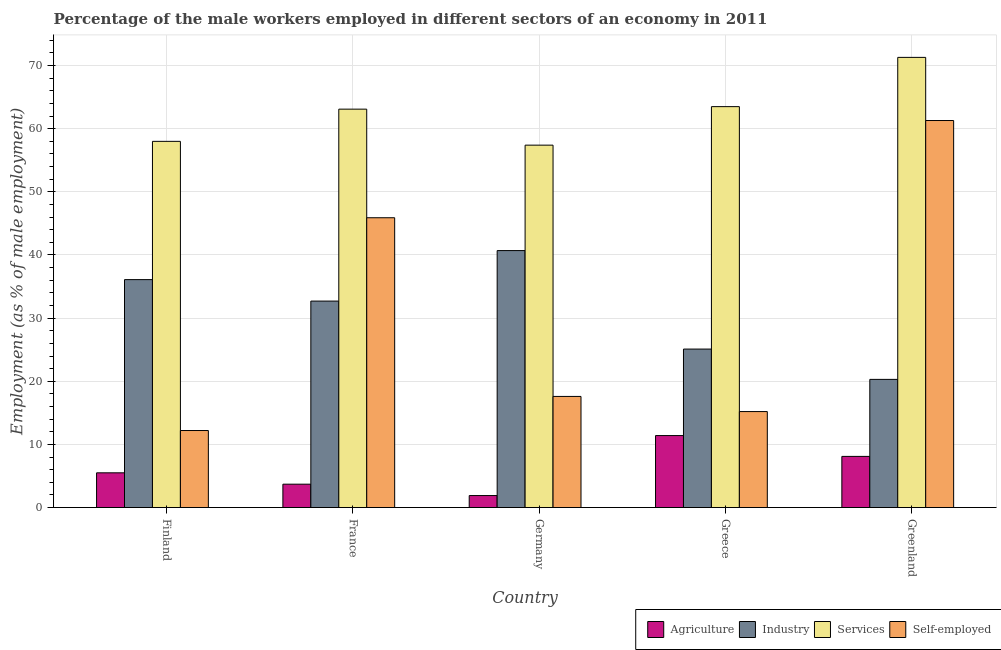How many different coloured bars are there?
Keep it short and to the point. 4. How many groups of bars are there?
Your response must be concise. 5. Are the number of bars on each tick of the X-axis equal?
Provide a succinct answer. Yes. What is the label of the 5th group of bars from the left?
Keep it short and to the point. Greenland. What is the percentage of male workers in industry in France?
Your answer should be very brief. 32.7. Across all countries, what is the maximum percentage of self employed male workers?
Give a very brief answer. 61.3. Across all countries, what is the minimum percentage of male workers in services?
Offer a very short reply. 57.4. In which country was the percentage of male workers in services minimum?
Make the answer very short. Germany. What is the total percentage of self employed male workers in the graph?
Offer a terse response. 152.2. What is the difference between the percentage of self employed male workers in Finland and that in Germany?
Offer a very short reply. -5.4. What is the difference between the percentage of self employed male workers in Greece and the percentage of male workers in industry in Finland?
Provide a short and direct response. -20.9. What is the average percentage of male workers in services per country?
Provide a short and direct response. 62.66. What is the difference between the percentage of male workers in industry and percentage of male workers in services in Germany?
Offer a terse response. -16.7. What is the ratio of the percentage of self employed male workers in Finland to that in Greenland?
Keep it short and to the point. 0.2. What is the difference between the highest and the second highest percentage of male workers in agriculture?
Make the answer very short. 3.3. What is the difference between the highest and the lowest percentage of male workers in industry?
Offer a very short reply. 20.4. Is the sum of the percentage of male workers in industry in France and Germany greater than the maximum percentage of male workers in services across all countries?
Your answer should be compact. Yes. Is it the case that in every country, the sum of the percentage of male workers in services and percentage of self employed male workers is greater than the sum of percentage of male workers in agriculture and percentage of male workers in industry?
Give a very brief answer. Yes. What does the 3rd bar from the left in Germany represents?
Make the answer very short. Services. What does the 3rd bar from the right in Greece represents?
Make the answer very short. Industry. Is it the case that in every country, the sum of the percentage of male workers in agriculture and percentage of male workers in industry is greater than the percentage of male workers in services?
Your response must be concise. No. Are all the bars in the graph horizontal?
Your answer should be very brief. No. What is the difference between two consecutive major ticks on the Y-axis?
Your answer should be compact. 10. Does the graph contain any zero values?
Make the answer very short. No. Where does the legend appear in the graph?
Ensure brevity in your answer.  Bottom right. How many legend labels are there?
Keep it short and to the point. 4. How are the legend labels stacked?
Your answer should be very brief. Horizontal. What is the title of the graph?
Keep it short and to the point. Percentage of the male workers employed in different sectors of an economy in 2011. What is the label or title of the X-axis?
Make the answer very short. Country. What is the label or title of the Y-axis?
Make the answer very short. Employment (as % of male employment). What is the Employment (as % of male employment) in Industry in Finland?
Ensure brevity in your answer.  36.1. What is the Employment (as % of male employment) in Self-employed in Finland?
Your answer should be compact. 12.2. What is the Employment (as % of male employment) of Agriculture in France?
Offer a very short reply. 3.7. What is the Employment (as % of male employment) in Industry in France?
Offer a terse response. 32.7. What is the Employment (as % of male employment) in Services in France?
Offer a very short reply. 63.1. What is the Employment (as % of male employment) in Self-employed in France?
Make the answer very short. 45.9. What is the Employment (as % of male employment) of Agriculture in Germany?
Ensure brevity in your answer.  1.9. What is the Employment (as % of male employment) in Industry in Germany?
Your answer should be compact. 40.7. What is the Employment (as % of male employment) in Services in Germany?
Offer a terse response. 57.4. What is the Employment (as % of male employment) of Self-employed in Germany?
Make the answer very short. 17.6. What is the Employment (as % of male employment) in Agriculture in Greece?
Offer a terse response. 11.4. What is the Employment (as % of male employment) of Industry in Greece?
Your response must be concise. 25.1. What is the Employment (as % of male employment) of Services in Greece?
Offer a very short reply. 63.5. What is the Employment (as % of male employment) in Self-employed in Greece?
Your answer should be very brief. 15.2. What is the Employment (as % of male employment) of Agriculture in Greenland?
Make the answer very short. 8.1. What is the Employment (as % of male employment) in Industry in Greenland?
Give a very brief answer. 20.3. What is the Employment (as % of male employment) of Services in Greenland?
Offer a terse response. 71.3. What is the Employment (as % of male employment) of Self-employed in Greenland?
Give a very brief answer. 61.3. Across all countries, what is the maximum Employment (as % of male employment) of Agriculture?
Your answer should be very brief. 11.4. Across all countries, what is the maximum Employment (as % of male employment) of Industry?
Make the answer very short. 40.7. Across all countries, what is the maximum Employment (as % of male employment) of Services?
Provide a succinct answer. 71.3. Across all countries, what is the maximum Employment (as % of male employment) of Self-employed?
Your response must be concise. 61.3. Across all countries, what is the minimum Employment (as % of male employment) of Agriculture?
Provide a succinct answer. 1.9. Across all countries, what is the minimum Employment (as % of male employment) of Industry?
Ensure brevity in your answer.  20.3. Across all countries, what is the minimum Employment (as % of male employment) of Services?
Make the answer very short. 57.4. Across all countries, what is the minimum Employment (as % of male employment) in Self-employed?
Provide a succinct answer. 12.2. What is the total Employment (as % of male employment) of Agriculture in the graph?
Your answer should be very brief. 30.6. What is the total Employment (as % of male employment) in Industry in the graph?
Keep it short and to the point. 154.9. What is the total Employment (as % of male employment) of Services in the graph?
Give a very brief answer. 313.3. What is the total Employment (as % of male employment) of Self-employed in the graph?
Offer a very short reply. 152.2. What is the difference between the Employment (as % of male employment) of Self-employed in Finland and that in France?
Offer a terse response. -33.7. What is the difference between the Employment (as % of male employment) of Agriculture in Finland and that in Germany?
Offer a very short reply. 3.6. What is the difference between the Employment (as % of male employment) of Industry in Finland and that in Germany?
Your response must be concise. -4.6. What is the difference between the Employment (as % of male employment) in Services in Finland and that in Germany?
Provide a short and direct response. 0.6. What is the difference between the Employment (as % of male employment) in Agriculture in Finland and that in Greece?
Provide a short and direct response. -5.9. What is the difference between the Employment (as % of male employment) of Self-employed in Finland and that in Greece?
Your answer should be very brief. -3. What is the difference between the Employment (as % of male employment) of Agriculture in Finland and that in Greenland?
Ensure brevity in your answer.  -2.6. What is the difference between the Employment (as % of male employment) in Industry in Finland and that in Greenland?
Your answer should be very brief. 15.8. What is the difference between the Employment (as % of male employment) of Self-employed in Finland and that in Greenland?
Provide a short and direct response. -49.1. What is the difference between the Employment (as % of male employment) in Agriculture in France and that in Germany?
Offer a very short reply. 1.8. What is the difference between the Employment (as % of male employment) in Industry in France and that in Germany?
Provide a short and direct response. -8. What is the difference between the Employment (as % of male employment) of Services in France and that in Germany?
Offer a very short reply. 5.7. What is the difference between the Employment (as % of male employment) of Self-employed in France and that in Germany?
Your answer should be very brief. 28.3. What is the difference between the Employment (as % of male employment) of Agriculture in France and that in Greece?
Ensure brevity in your answer.  -7.7. What is the difference between the Employment (as % of male employment) of Industry in France and that in Greece?
Keep it short and to the point. 7.6. What is the difference between the Employment (as % of male employment) in Services in France and that in Greece?
Your response must be concise. -0.4. What is the difference between the Employment (as % of male employment) in Self-employed in France and that in Greece?
Your answer should be compact. 30.7. What is the difference between the Employment (as % of male employment) of Agriculture in France and that in Greenland?
Your answer should be very brief. -4.4. What is the difference between the Employment (as % of male employment) in Industry in France and that in Greenland?
Your response must be concise. 12.4. What is the difference between the Employment (as % of male employment) of Services in France and that in Greenland?
Offer a terse response. -8.2. What is the difference between the Employment (as % of male employment) of Self-employed in France and that in Greenland?
Your response must be concise. -15.4. What is the difference between the Employment (as % of male employment) in Agriculture in Germany and that in Greece?
Your answer should be very brief. -9.5. What is the difference between the Employment (as % of male employment) of Services in Germany and that in Greece?
Your answer should be compact. -6.1. What is the difference between the Employment (as % of male employment) in Self-employed in Germany and that in Greece?
Provide a succinct answer. 2.4. What is the difference between the Employment (as % of male employment) in Industry in Germany and that in Greenland?
Provide a succinct answer. 20.4. What is the difference between the Employment (as % of male employment) in Services in Germany and that in Greenland?
Make the answer very short. -13.9. What is the difference between the Employment (as % of male employment) of Self-employed in Germany and that in Greenland?
Offer a terse response. -43.7. What is the difference between the Employment (as % of male employment) in Services in Greece and that in Greenland?
Offer a very short reply. -7.8. What is the difference between the Employment (as % of male employment) of Self-employed in Greece and that in Greenland?
Your response must be concise. -46.1. What is the difference between the Employment (as % of male employment) of Agriculture in Finland and the Employment (as % of male employment) of Industry in France?
Your answer should be compact. -27.2. What is the difference between the Employment (as % of male employment) of Agriculture in Finland and the Employment (as % of male employment) of Services in France?
Offer a very short reply. -57.6. What is the difference between the Employment (as % of male employment) of Agriculture in Finland and the Employment (as % of male employment) of Self-employed in France?
Provide a short and direct response. -40.4. What is the difference between the Employment (as % of male employment) in Industry in Finland and the Employment (as % of male employment) in Services in France?
Your answer should be very brief. -27. What is the difference between the Employment (as % of male employment) in Agriculture in Finland and the Employment (as % of male employment) in Industry in Germany?
Keep it short and to the point. -35.2. What is the difference between the Employment (as % of male employment) in Agriculture in Finland and the Employment (as % of male employment) in Services in Germany?
Your answer should be compact. -51.9. What is the difference between the Employment (as % of male employment) of Agriculture in Finland and the Employment (as % of male employment) of Self-employed in Germany?
Make the answer very short. -12.1. What is the difference between the Employment (as % of male employment) in Industry in Finland and the Employment (as % of male employment) in Services in Germany?
Keep it short and to the point. -21.3. What is the difference between the Employment (as % of male employment) in Industry in Finland and the Employment (as % of male employment) in Self-employed in Germany?
Keep it short and to the point. 18.5. What is the difference between the Employment (as % of male employment) in Services in Finland and the Employment (as % of male employment) in Self-employed in Germany?
Your answer should be compact. 40.4. What is the difference between the Employment (as % of male employment) of Agriculture in Finland and the Employment (as % of male employment) of Industry in Greece?
Provide a succinct answer. -19.6. What is the difference between the Employment (as % of male employment) in Agriculture in Finland and the Employment (as % of male employment) in Services in Greece?
Offer a terse response. -58. What is the difference between the Employment (as % of male employment) in Industry in Finland and the Employment (as % of male employment) in Services in Greece?
Give a very brief answer. -27.4. What is the difference between the Employment (as % of male employment) in Industry in Finland and the Employment (as % of male employment) in Self-employed in Greece?
Give a very brief answer. 20.9. What is the difference between the Employment (as % of male employment) in Services in Finland and the Employment (as % of male employment) in Self-employed in Greece?
Your answer should be compact. 42.8. What is the difference between the Employment (as % of male employment) of Agriculture in Finland and the Employment (as % of male employment) of Industry in Greenland?
Offer a very short reply. -14.8. What is the difference between the Employment (as % of male employment) of Agriculture in Finland and the Employment (as % of male employment) of Services in Greenland?
Ensure brevity in your answer.  -65.8. What is the difference between the Employment (as % of male employment) of Agriculture in Finland and the Employment (as % of male employment) of Self-employed in Greenland?
Provide a short and direct response. -55.8. What is the difference between the Employment (as % of male employment) in Industry in Finland and the Employment (as % of male employment) in Services in Greenland?
Your response must be concise. -35.2. What is the difference between the Employment (as % of male employment) in Industry in Finland and the Employment (as % of male employment) in Self-employed in Greenland?
Provide a short and direct response. -25.2. What is the difference between the Employment (as % of male employment) of Services in Finland and the Employment (as % of male employment) of Self-employed in Greenland?
Keep it short and to the point. -3.3. What is the difference between the Employment (as % of male employment) in Agriculture in France and the Employment (as % of male employment) in Industry in Germany?
Your answer should be very brief. -37. What is the difference between the Employment (as % of male employment) in Agriculture in France and the Employment (as % of male employment) in Services in Germany?
Your answer should be compact. -53.7. What is the difference between the Employment (as % of male employment) in Industry in France and the Employment (as % of male employment) in Services in Germany?
Give a very brief answer. -24.7. What is the difference between the Employment (as % of male employment) in Services in France and the Employment (as % of male employment) in Self-employed in Germany?
Offer a very short reply. 45.5. What is the difference between the Employment (as % of male employment) of Agriculture in France and the Employment (as % of male employment) of Industry in Greece?
Make the answer very short. -21.4. What is the difference between the Employment (as % of male employment) of Agriculture in France and the Employment (as % of male employment) of Services in Greece?
Offer a very short reply. -59.8. What is the difference between the Employment (as % of male employment) in Agriculture in France and the Employment (as % of male employment) in Self-employed in Greece?
Your response must be concise. -11.5. What is the difference between the Employment (as % of male employment) in Industry in France and the Employment (as % of male employment) in Services in Greece?
Give a very brief answer. -30.8. What is the difference between the Employment (as % of male employment) of Services in France and the Employment (as % of male employment) of Self-employed in Greece?
Keep it short and to the point. 47.9. What is the difference between the Employment (as % of male employment) in Agriculture in France and the Employment (as % of male employment) in Industry in Greenland?
Make the answer very short. -16.6. What is the difference between the Employment (as % of male employment) of Agriculture in France and the Employment (as % of male employment) of Services in Greenland?
Your answer should be very brief. -67.6. What is the difference between the Employment (as % of male employment) of Agriculture in France and the Employment (as % of male employment) of Self-employed in Greenland?
Offer a very short reply. -57.6. What is the difference between the Employment (as % of male employment) of Industry in France and the Employment (as % of male employment) of Services in Greenland?
Provide a short and direct response. -38.6. What is the difference between the Employment (as % of male employment) of Industry in France and the Employment (as % of male employment) of Self-employed in Greenland?
Provide a short and direct response. -28.6. What is the difference between the Employment (as % of male employment) in Agriculture in Germany and the Employment (as % of male employment) in Industry in Greece?
Provide a short and direct response. -23.2. What is the difference between the Employment (as % of male employment) in Agriculture in Germany and the Employment (as % of male employment) in Services in Greece?
Ensure brevity in your answer.  -61.6. What is the difference between the Employment (as % of male employment) of Agriculture in Germany and the Employment (as % of male employment) of Self-employed in Greece?
Your answer should be compact. -13.3. What is the difference between the Employment (as % of male employment) in Industry in Germany and the Employment (as % of male employment) in Services in Greece?
Give a very brief answer. -22.8. What is the difference between the Employment (as % of male employment) of Services in Germany and the Employment (as % of male employment) of Self-employed in Greece?
Your answer should be very brief. 42.2. What is the difference between the Employment (as % of male employment) of Agriculture in Germany and the Employment (as % of male employment) of Industry in Greenland?
Your answer should be compact. -18.4. What is the difference between the Employment (as % of male employment) in Agriculture in Germany and the Employment (as % of male employment) in Services in Greenland?
Your answer should be very brief. -69.4. What is the difference between the Employment (as % of male employment) of Agriculture in Germany and the Employment (as % of male employment) of Self-employed in Greenland?
Offer a terse response. -59.4. What is the difference between the Employment (as % of male employment) of Industry in Germany and the Employment (as % of male employment) of Services in Greenland?
Keep it short and to the point. -30.6. What is the difference between the Employment (as % of male employment) in Industry in Germany and the Employment (as % of male employment) in Self-employed in Greenland?
Ensure brevity in your answer.  -20.6. What is the difference between the Employment (as % of male employment) in Agriculture in Greece and the Employment (as % of male employment) in Industry in Greenland?
Ensure brevity in your answer.  -8.9. What is the difference between the Employment (as % of male employment) of Agriculture in Greece and the Employment (as % of male employment) of Services in Greenland?
Provide a short and direct response. -59.9. What is the difference between the Employment (as % of male employment) in Agriculture in Greece and the Employment (as % of male employment) in Self-employed in Greenland?
Your answer should be very brief. -49.9. What is the difference between the Employment (as % of male employment) of Industry in Greece and the Employment (as % of male employment) of Services in Greenland?
Provide a succinct answer. -46.2. What is the difference between the Employment (as % of male employment) of Industry in Greece and the Employment (as % of male employment) of Self-employed in Greenland?
Provide a short and direct response. -36.2. What is the difference between the Employment (as % of male employment) in Services in Greece and the Employment (as % of male employment) in Self-employed in Greenland?
Make the answer very short. 2.2. What is the average Employment (as % of male employment) of Agriculture per country?
Offer a very short reply. 6.12. What is the average Employment (as % of male employment) in Industry per country?
Offer a very short reply. 30.98. What is the average Employment (as % of male employment) of Services per country?
Ensure brevity in your answer.  62.66. What is the average Employment (as % of male employment) in Self-employed per country?
Give a very brief answer. 30.44. What is the difference between the Employment (as % of male employment) of Agriculture and Employment (as % of male employment) of Industry in Finland?
Offer a terse response. -30.6. What is the difference between the Employment (as % of male employment) of Agriculture and Employment (as % of male employment) of Services in Finland?
Offer a very short reply. -52.5. What is the difference between the Employment (as % of male employment) of Industry and Employment (as % of male employment) of Services in Finland?
Ensure brevity in your answer.  -21.9. What is the difference between the Employment (as % of male employment) of Industry and Employment (as % of male employment) of Self-employed in Finland?
Offer a terse response. 23.9. What is the difference between the Employment (as % of male employment) of Services and Employment (as % of male employment) of Self-employed in Finland?
Make the answer very short. 45.8. What is the difference between the Employment (as % of male employment) in Agriculture and Employment (as % of male employment) in Industry in France?
Provide a succinct answer. -29. What is the difference between the Employment (as % of male employment) in Agriculture and Employment (as % of male employment) in Services in France?
Offer a terse response. -59.4. What is the difference between the Employment (as % of male employment) of Agriculture and Employment (as % of male employment) of Self-employed in France?
Keep it short and to the point. -42.2. What is the difference between the Employment (as % of male employment) of Industry and Employment (as % of male employment) of Services in France?
Provide a short and direct response. -30.4. What is the difference between the Employment (as % of male employment) in Agriculture and Employment (as % of male employment) in Industry in Germany?
Provide a succinct answer. -38.8. What is the difference between the Employment (as % of male employment) in Agriculture and Employment (as % of male employment) in Services in Germany?
Give a very brief answer. -55.5. What is the difference between the Employment (as % of male employment) of Agriculture and Employment (as % of male employment) of Self-employed in Germany?
Ensure brevity in your answer.  -15.7. What is the difference between the Employment (as % of male employment) of Industry and Employment (as % of male employment) of Services in Germany?
Offer a terse response. -16.7. What is the difference between the Employment (as % of male employment) in Industry and Employment (as % of male employment) in Self-employed in Germany?
Provide a short and direct response. 23.1. What is the difference between the Employment (as % of male employment) of Services and Employment (as % of male employment) of Self-employed in Germany?
Provide a short and direct response. 39.8. What is the difference between the Employment (as % of male employment) of Agriculture and Employment (as % of male employment) of Industry in Greece?
Provide a short and direct response. -13.7. What is the difference between the Employment (as % of male employment) of Agriculture and Employment (as % of male employment) of Services in Greece?
Offer a terse response. -52.1. What is the difference between the Employment (as % of male employment) of Industry and Employment (as % of male employment) of Services in Greece?
Your answer should be very brief. -38.4. What is the difference between the Employment (as % of male employment) of Industry and Employment (as % of male employment) of Self-employed in Greece?
Your answer should be compact. 9.9. What is the difference between the Employment (as % of male employment) of Services and Employment (as % of male employment) of Self-employed in Greece?
Make the answer very short. 48.3. What is the difference between the Employment (as % of male employment) in Agriculture and Employment (as % of male employment) in Industry in Greenland?
Ensure brevity in your answer.  -12.2. What is the difference between the Employment (as % of male employment) of Agriculture and Employment (as % of male employment) of Services in Greenland?
Make the answer very short. -63.2. What is the difference between the Employment (as % of male employment) in Agriculture and Employment (as % of male employment) in Self-employed in Greenland?
Offer a terse response. -53.2. What is the difference between the Employment (as % of male employment) in Industry and Employment (as % of male employment) in Services in Greenland?
Offer a terse response. -51. What is the difference between the Employment (as % of male employment) in Industry and Employment (as % of male employment) in Self-employed in Greenland?
Offer a very short reply. -41. What is the difference between the Employment (as % of male employment) in Services and Employment (as % of male employment) in Self-employed in Greenland?
Your response must be concise. 10. What is the ratio of the Employment (as % of male employment) of Agriculture in Finland to that in France?
Give a very brief answer. 1.49. What is the ratio of the Employment (as % of male employment) in Industry in Finland to that in France?
Provide a succinct answer. 1.1. What is the ratio of the Employment (as % of male employment) of Services in Finland to that in France?
Ensure brevity in your answer.  0.92. What is the ratio of the Employment (as % of male employment) in Self-employed in Finland to that in France?
Give a very brief answer. 0.27. What is the ratio of the Employment (as % of male employment) of Agriculture in Finland to that in Germany?
Provide a succinct answer. 2.89. What is the ratio of the Employment (as % of male employment) of Industry in Finland to that in Germany?
Provide a succinct answer. 0.89. What is the ratio of the Employment (as % of male employment) in Services in Finland to that in Germany?
Make the answer very short. 1.01. What is the ratio of the Employment (as % of male employment) in Self-employed in Finland to that in Germany?
Your response must be concise. 0.69. What is the ratio of the Employment (as % of male employment) of Agriculture in Finland to that in Greece?
Your answer should be compact. 0.48. What is the ratio of the Employment (as % of male employment) in Industry in Finland to that in Greece?
Provide a short and direct response. 1.44. What is the ratio of the Employment (as % of male employment) in Services in Finland to that in Greece?
Ensure brevity in your answer.  0.91. What is the ratio of the Employment (as % of male employment) of Self-employed in Finland to that in Greece?
Offer a very short reply. 0.8. What is the ratio of the Employment (as % of male employment) in Agriculture in Finland to that in Greenland?
Give a very brief answer. 0.68. What is the ratio of the Employment (as % of male employment) in Industry in Finland to that in Greenland?
Your answer should be very brief. 1.78. What is the ratio of the Employment (as % of male employment) of Services in Finland to that in Greenland?
Make the answer very short. 0.81. What is the ratio of the Employment (as % of male employment) in Self-employed in Finland to that in Greenland?
Offer a terse response. 0.2. What is the ratio of the Employment (as % of male employment) of Agriculture in France to that in Germany?
Give a very brief answer. 1.95. What is the ratio of the Employment (as % of male employment) in Industry in France to that in Germany?
Your answer should be compact. 0.8. What is the ratio of the Employment (as % of male employment) in Services in France to that in Germany?
Provide a succinct answer. 1.1. What is the ratio of the Employment (as % of male employment) of Self-employed in France to that in Germany?
Your response must be concise. 2.61. What is the ratio of the Employment (as % of male employment) in Agriculture in France to that in Greece?
Ensure brevity in your answer.  0.32. What is the ratio of the Employment (as % of male employment) of Industry in France to that in Greece?
Make the answer very short. 1.3. What is the ratio of the Employment (as % of male employment) in Services in France to that in Greece?
Your answer should be very brief. 0.99. What is the ratio of the Employment (as % of male employment) in Self-employed in France to that in Greece?
Make the answer very short. 3.02. What is the ratio of the Employment (as % of male employment) in Agriculture in France to that in Greenland?
Give a very brief answer. 0.46. What is the ratio of the Employment (as % of male employment) in Industry in France to that in Greenland?
Ensure brevity in your answer.  1.61. What is the ratio of the Employment (as % of male employment) in Services in France to that in Greenland?
Your answer should be very brief. 0.89. What is the ratio of the Employment (as % of male employment) of Self-employed in France to that in Greenland?
Provide a succinct answer. 0.75. What is the ratio of the Employment (as % of male employment) in Industry in Germany to that in Greece?
Keep it short and to the point. 1.62. What is the ratio of the Employment (as % of male employment) of Services in Germany to that in Greece?
Keep it short and to the point. 0.9. What is the ratio of the Employment (as % of male employment) in Self-employed in Germany to that in Greece?
Make the answer very short. 1.16. What is the ratio of the Employment (as % of male employment) in Agriculture in Germany to that in Greenland?
Provide a short and direct response. 0.23. What is the ratio of the Employment (as % of male employment) in Industry in Germany to that in Greenland?
Make the answer very short. 2. What is the ratio of the Employment (as % of male employment) in Services in Germany to that in Greenland?
Provide a succinct answer. 0.81. What is the ratio of the Employment (as % of male employment) of Self-employed in Germany to that in Greenland?
Your answer should be compact. 0.29. What is the ratio of the Employment (as % of male employment) of Agriculture in Greece to that in Greenland?
Your answer should be compact. 1.41. What is the ratio of the Employment (as % of male employment) of Industry in Greece to that in Greenland?
Offer a terse response. 1.24. What is the ratio of the Employment (as % of male employment) in Services in Greece to that in Greenland?
Offer a very short reply. 0.89. What is the ratio of the Employment (as % of male employment) in Self-employed in Greece to that in Greenland?
Your answer should be very brief. 0.25. What is the difference between the highest and the second highest Employment (as % of male employment) of Services?
Your response must be concise. 7.8. What is the difference between the highest and the lowest Employment (as % of male employment) in Industry?
Your answer should be compact. 20.4. What is the difference between the highest and the lowest Employment (as % of male employment) in Self-employed?
Give a very brief answer. 49.1. 